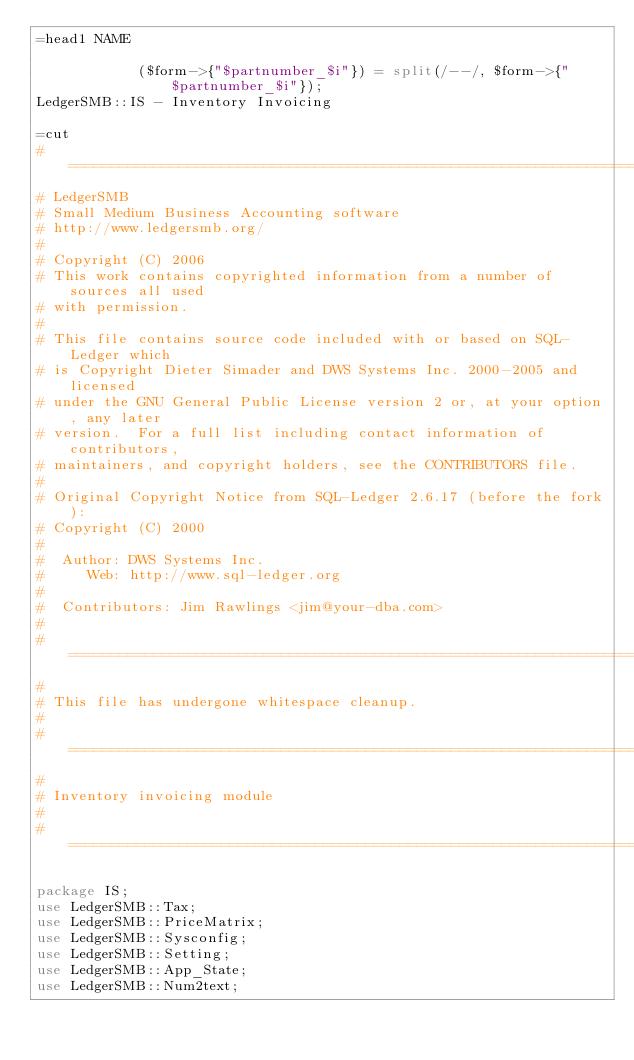<code> <loc_0><loc_0><loc_500><loc_500><_Perl_>=head1 NAME

            ($form->{"$partnumber_$i"}) = split(/--/, $form->{"$partnumber_$i"});
LedgerSMB::IS - Inventory Invoicing

=cut
#====================================================================
# LedgerSMB
# Small Medium Business Accounting software
# http://www.ledgersmb.org/
#
# Copyright (C) 2006
# This work contains copyrighted information from a number of sources all used
# with permission.
#
# This file contains source code included with or based on SQL-Ledger which
# is Copyright Dieter Simader and DWS Systems Inc. 2000-2005 and licensed
# under the GNU General Public License version 2 or, at your option, any later
# version.  For a full list including contact information of contributors,
# maintainers, and copyright holders, see the CONTRIBUTORS file.
#
# Original Copyright Notice from SQL-Ledger 2.6.17 (before the fork):
# Copyright (C) 2000
#
#  Author: DWS Systems Inc.
#     Web: http://www.sql-ledger.org
#
#  Contributors: Jim Rawlings <jim@your-dba.com>
#
#======================================================================
#
# This file has undergone whitespace cleanup.
#
#======================================================================
#
# Inventory invoicing module
#
#======================================================================

package IS;
use LedgerSMB::Tax;
use LedgerSMB::PriceMatrix;
use LedgerSMB::Sysconfig;
use LedgerSMB::Setting;
use LedgerSMB::App_State;
use LedgerSMB::Num2text;</code> 